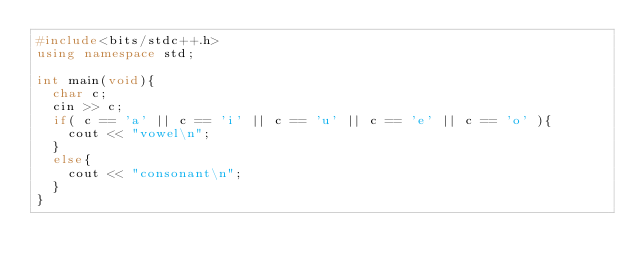<code> <loc_0><loc_0><loc_500><loc_500><_C++_>#include<bits/stdc++.h>
using namespace std;

int main(void){
  char c;
  cin >> c;
  if( c == 'a' || c == 'i' || c == 'u' || c == 'e' || c == 'o' ){
    cout << "vowel\n";
  }
  else{
    cout << "consonant\n";
  }
}</code> 